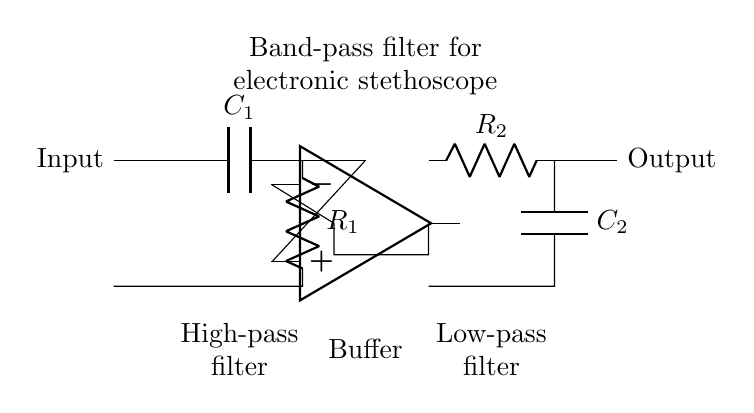What is the purpose of this circuit? This circuit is a band-pass filter, which is designed to isolate specific frequencies associated with heart and lung sounds for an electronic stethoscope. It allows certain frequencies to pass while attenuating others.
Answer: Band-pass filter What types of components are used in the high-pass section? The high-pass section includes a capacitor and a resistor. The capacitor blocks low-frequency signals while allowing higher frequencies to pass through, combined with the resistor to set the cutoff frequency.
Answer: Capacitor and Resistor What is the role of the buffer in this circuit? The buffer, represented by the operational amplifier, is used to isolate the stages of the filter. It helps maintain signal integrity and prevents loading effects from the following circuit stages while also providing gain if necessary.
Answer: Isolation What is the configuration for the low-pass filter? The low-pass filter is configured with a resistor followed by a capacitor. This setup allows low frequencies to pass through while attenuating higher frequencies, defining the cutoff frequency of the filter.
Answer: Resistor and Capacitor How many main filtering stages are present in this circuit? There are three main filtering stages in this circuit: a high-pass filter stage, a buffer stage, and a low-pass filter stage, collectively forming the band-pass filter used here.
Answer: Three What is the fixation point for R1 in the high-pass filter? R1 is connected to the output of the capacitor C1 and further feeds into the ground at the lower point, allowing it to work as part of the high-pass filter along with C1.
Answer: Output of C1 to ground What would happen if C2 was removed from the circuit? Removing C2 would disrupt the low-pass filter functionality, resulting in the inability to attenuate the higher frequencies, which could allow unwanted noise and artifacts into the output signal.
Answer: Disruption of low-pass filter 